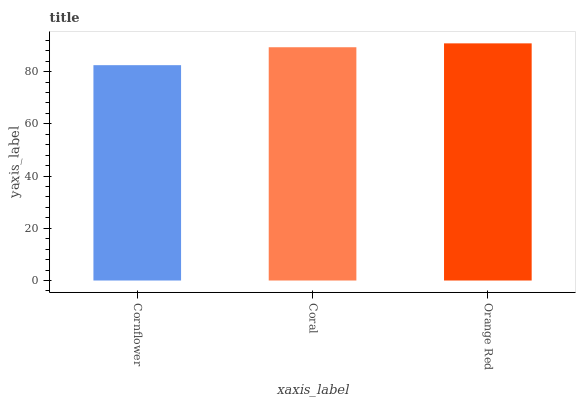Is Cornflower the minimum?
Answer yes or no. Yes. Is Orange Red the maximum?
Answer yes or no. Yes. Is Coral the minimum?
Answer yes or no. No. Is Coral the maximum?
Answer yes or no. No. Is Coral greater than Cornflower?
Answer yes or no. Yes. Is Cornflower less than Coral?
Answer yes or no. Yes. Is Cornflower greater than Coral?
Answer yes or no. No. Is Coral less than Cornflower?
Answer yes or no. No. Is Coral the high median?
Answer yes or no. Yes. Is Coral the low median?
Answer yes or no. Yes. Is Orange Red the high median?
Answer yes or no. No. Is Orange Red the low median?
Answer yes or no. No. 